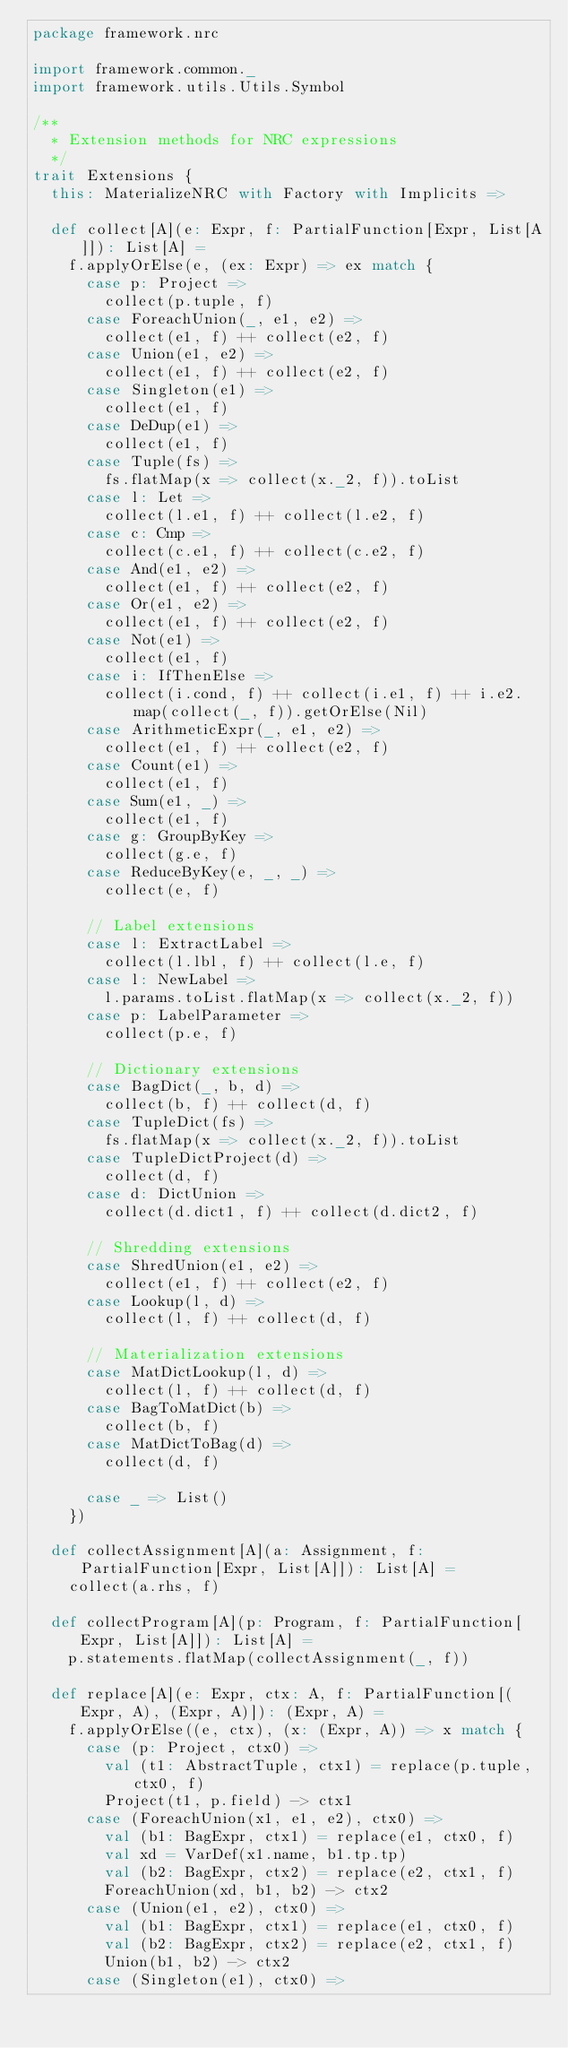Convert code to text. <code><loc_0><loc_0><loc_500><loc_500><_Scala_>package framework.nrc

import framework.common._
import framework.utils.Utils.Symbol

/**
  * Extension methods for NRC expressions
  */
trait Extensions {
  this: MaterializeNRC with Factory with Implicits =>

  def collect[A](e: Expr, f: PartialFunction[Expr, List[A]]): List[A] =
    f.applyOrElse(e, (ex: Expr) => ex match {
      case p: Project =>
        collect(p.tuple, f)
      case ForeachUnion(_, e1, e2) =>
        collect(e1, f) ++ collect(e2, f)
      case Union(e1, e2) =>
        collect(e1, f) ++ collect(e2, f)
      case Singleton(e1) =>
        collect(e1, f)
      case DeDup(e1) =>
        collect(e1, f)
      case Tuple(fs) =>
        fs.flatMap(x => collect(x._2, f)).toList
      case l: Let =>
        collect(l.e1, f) ++ collect(l.e2, f)
      case c: Cmp =>
        collect(c.e1, f) ++ collect(c.e2, f)
      case And(e1, e2) =>
        collect(e1, f) ++ collect(e2, f)
      case Or(e1, e2) =>
        collect(e1, f) ++ collect(e2, f)
      case Not(e1) =>
        collect(e1, f)
      case i: IfThenElse =>
        collect(i.cond, f) ++ collect(i.e1, f) ++ i.e2.map(collect(_, f)).getOrElse(Nil)
      case ArithmeticExpr(_, e1, e2) =>
        collect(e1, f) ++ collect(e2, f)
      case Count(e1) =>
        collect(e1, f)
      case Sum(e1, _) =>
        collect(e1, f)
      case g: GroupByKey =>
        collect(g.e, f)
      case ReduceByKey(e, _, _) =>
        collect(e, f)

      // Label extensions
      case l: ExtractLabel =>
        collect(l.lbl, f) ++ collect(l.e, f)
      case l: NewLabel =>
        l.params.toList.flatMap(x => collect(x._2, f))
      case p: LabelParameter =>
        collect(p.e, f)

      // Dictionary extensions
      case BagDict(_, b, d) =>
        collect(b, f) ++ collect(d, f)
      case TupleDict(fs) =>
        fs.flatMap(x => collect(x._2, f)).toList
      case TupleDictProject(d) =>
        collect(d, f)
      case d: DictUnion =>
        collect(d.dict1, f) ++ collect(d.dict2, f)

      // Shredding extensions
      case ShredUnion(e1, e2) =>
        collect(e1, f) ++ collect(e2, f)
      case Lookup(l, d) =>
        collect(l, f) ++ collect(d, f)

      // Materialization extensions
      case MatDictLookup(l, d) =>
        collect(l, f) ++ collect(d, f)
      case BagToMatDict(b) =>
        collect(b, f)
      case MatDictToBag(d) =>
        collect(d, f)

      case _ => List()
    })

  def collectAssignment[A](a: Assignment, f: PartialFunction[Expr, List[A]]): List[A] =
    collect(a.rhs, f)

  def collectProgram[A](p: Program, f: PartialFunction[Expr, List[A]]): List[A] =
    p.statements.flatMap(collectAssignment(_, f))

  def replace[A](e: Expr, ctx: A, f: PartialFunction[(Expr, A), (Expr, A)]): (Expr, A) =
    f.applyOrElse((e, ctx), (x: (Expr, A)) => x match {
      case (p: Project, ctx0) =>
        val (t1: AbstractTuple, ctx1) = replace(p.tuple, ctx0, f)
        Project(t1, p.field) -> ctx1
      case (ForeachUnion(x1, e1, e2), ctx0) =>
        val (b1: BagExpr, ctx1) = replace(e1, ctx0, f)
        val xd = VarDef(x1.name, b1.tp.tp)
        val (b2: BagExpr, ctx2) = replace(e2, ctx1, f)
        ForeachUnion(xd, b1, b2) -> ctx2
      case (Union(e1, e2), ctx0) =>
        val (b1: BagExpr, ctx1) = replace(e1, ctx0, f)
        val (b2: BagExpr, ctx2) = replace(e2, ctx1, f)
        Union(b1, b2) -> ctx2
      case (Singleton(e1), ctx0) =></code> 